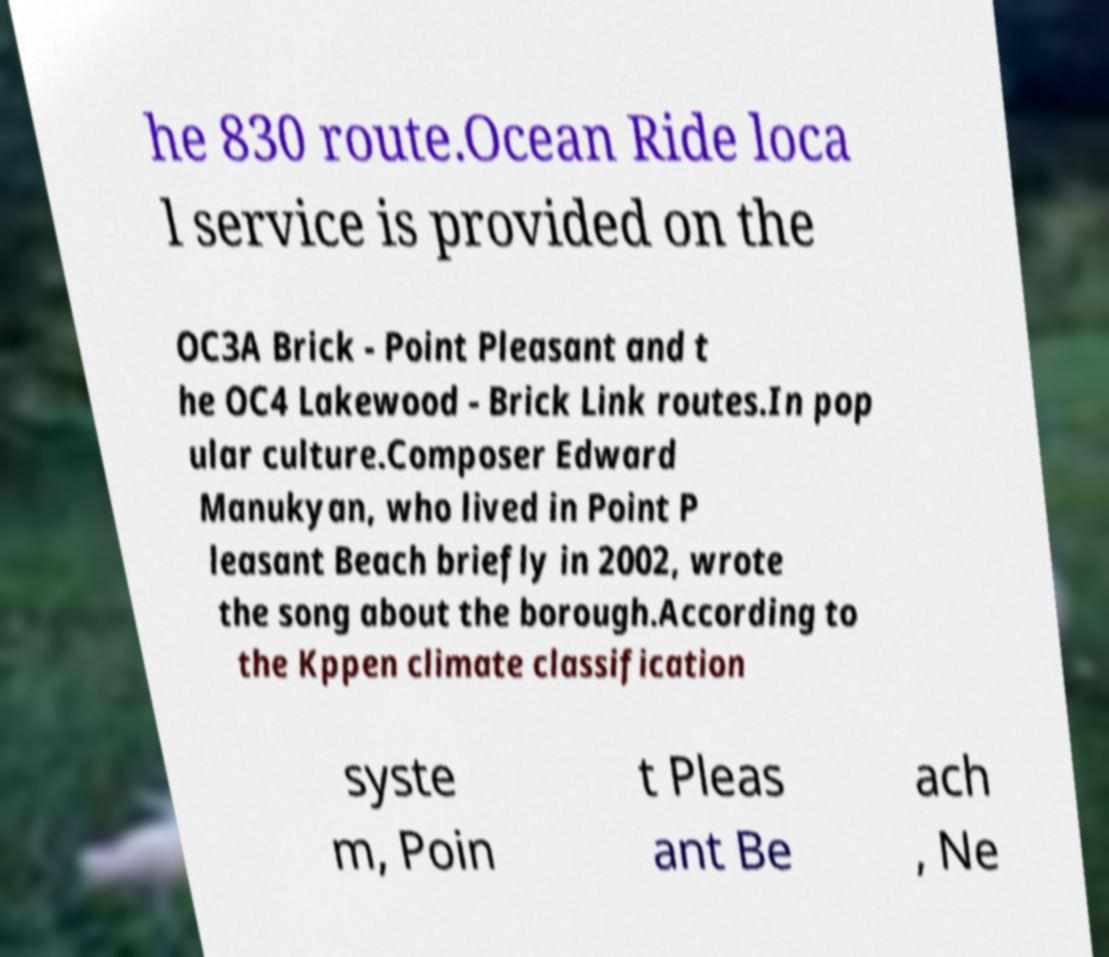I need the written content from this picture converted into text. Can you do that? he 830 route.Ocean Ride loca l service is provided on the OC3A Brick - Point Pleasant and t he OC4 Lakewood - Brick Link routes.In pop ular culture.Composer Edward Manukyan, who lived in Point P leasant Beach briefly in 2002, wrote the song about the borough.According to the Kppen climate classification syste m, Poin t Pleas ant Be ach , Ne 